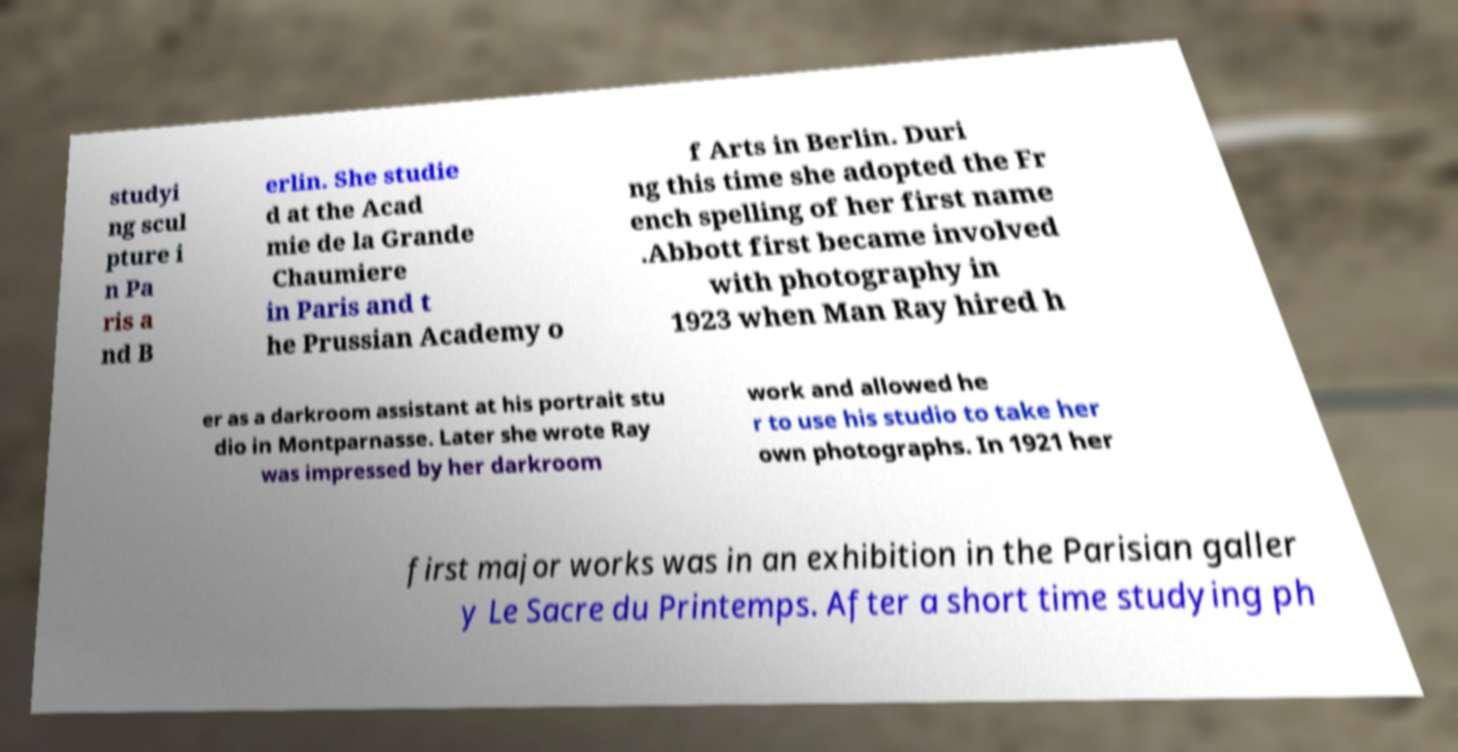For documentation purposes, I need the text within this image transcribed. Could you provide that? studyi ng scul pture i n Pa ris a nd B erlin. She studie d at the Acad mie de la Grande Chaumiere in Paris and t he Prussian Academy o f Arts in Berlin. Duri ng this time she adopted the Fr ench spelling of her first name .Abbott first became involved with photography in 1923 when Man Ray hired h er as a darkroom assistant at his portrait stu dio in Montparnasse. Later she wrote Ray was impressed by her darkroom work and allowed he r to use his studio to take her own photographs. In 1921 her first major works was in an exhibition in the Parisian galler y Le Sacre du Printemps. After a short time studying ph 